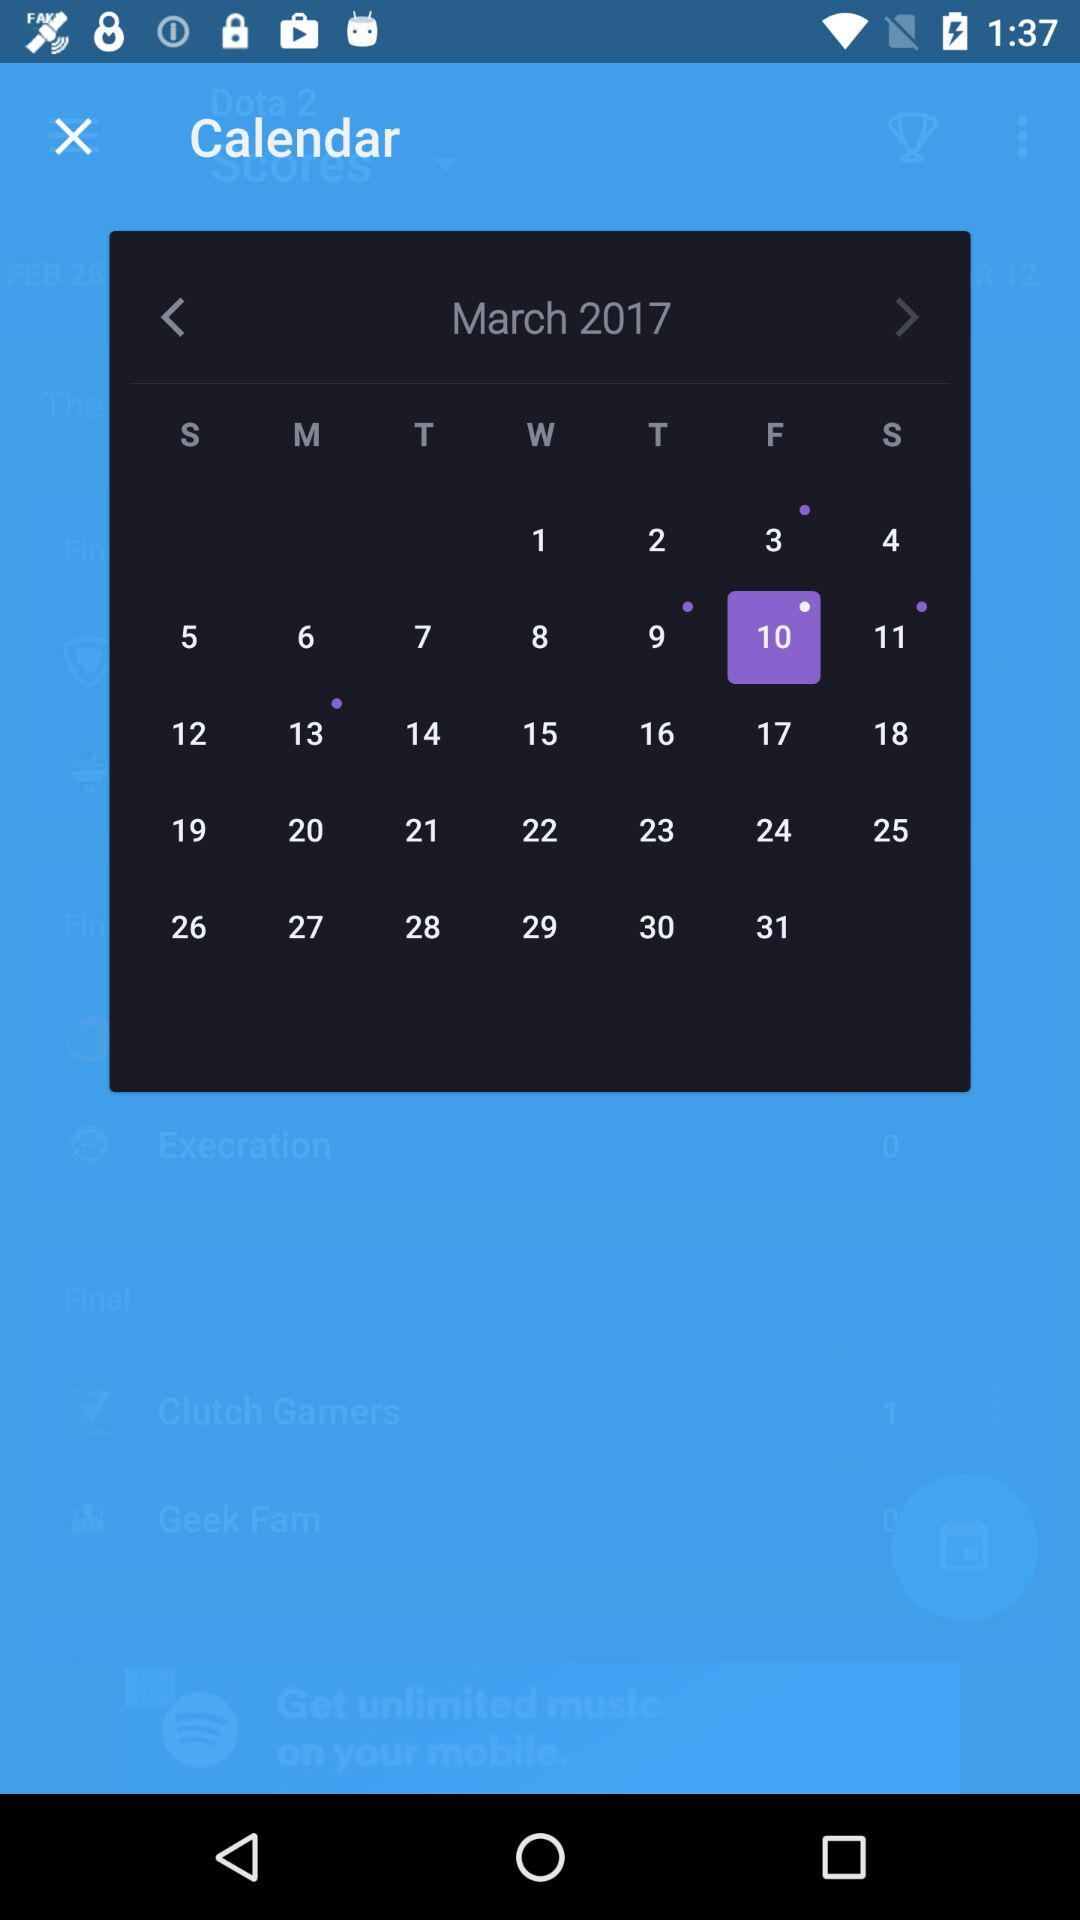What is the day of the selected date? The day of the selected date is Friday. 